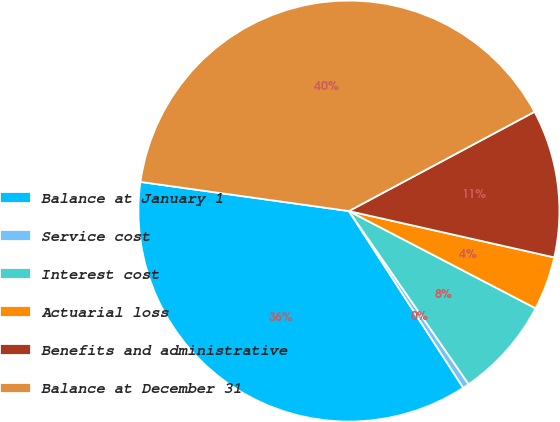Convert chart. <chart><loc_0><loc_0><loc_500><loc_500><pie_chart><fcel>Balance at January 1<fcel>Service cost<fcel>Interest cost<fcel>Actuarial loss<fcel>Benefits and administrative<fcel>Balance at December 31<nl><fcel>36.35%<fcel>0.49%<fcel>7.73%<fcel>4.11%<fcel>11.35%<fcel>39.97%<nl></chart> 